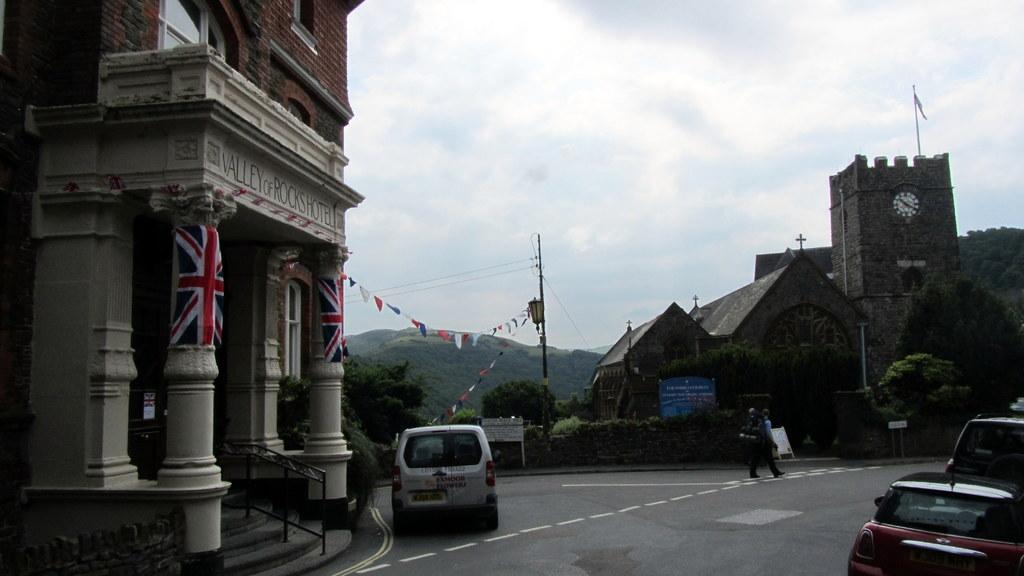<image>
Describe the image concisely. A landscape shot of a van in front of a hotel called Valley of Rocks Hotel 